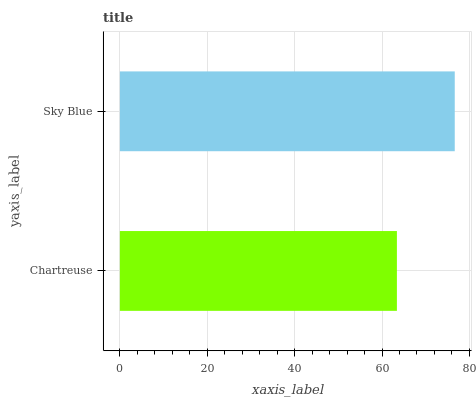Is Chartreuse the minimum?
Answer yes or no. Yes. Is Sky Blue the maximum?
Answer yes or no. Yes. Is Sky Blue the minimum?
Answer yes or no. No. Is Sky Blue greater than Chartreuse?
Answer yes or no. Yes. Is Chartreuse less than Sky Blue?
Answer yes or no. Yes. Is Chartreuse greater than Sky Blue?
Answer yes or no. No. Is Sky Blue less than Chartreuse?
Answer yes or no. No. Is Sky Blue the high median?
Answer yes or no. Yes. Is Chartreuse the low median?
Answer yes or no. Yes. Is Chartreuse the high median?
Answer yes or no. No. Is Sky Blue the low median?
Answer yes or no. No. 